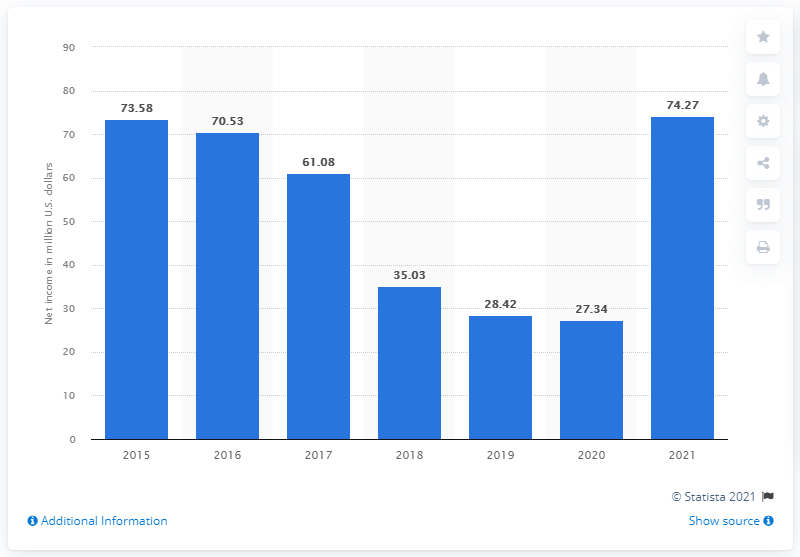Specify some key components in this picture. The net income of Hibbett Sports in 2021 was 74.27. 